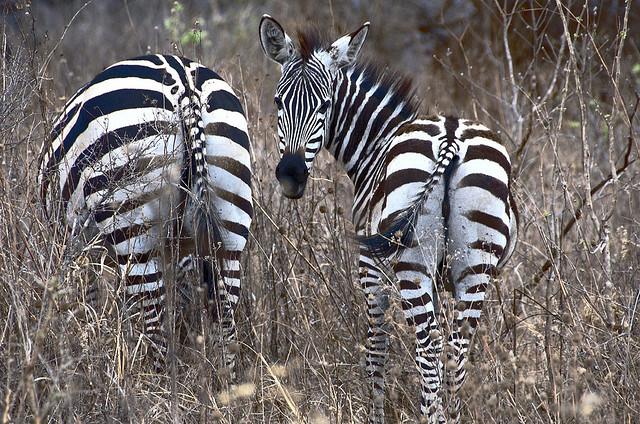Which zebra is larger?
Concise answer only. Left. Is one zebra turning its head?
Write a very short answer. Yes. Can you see their butts?
Concise answer only. Yes. 